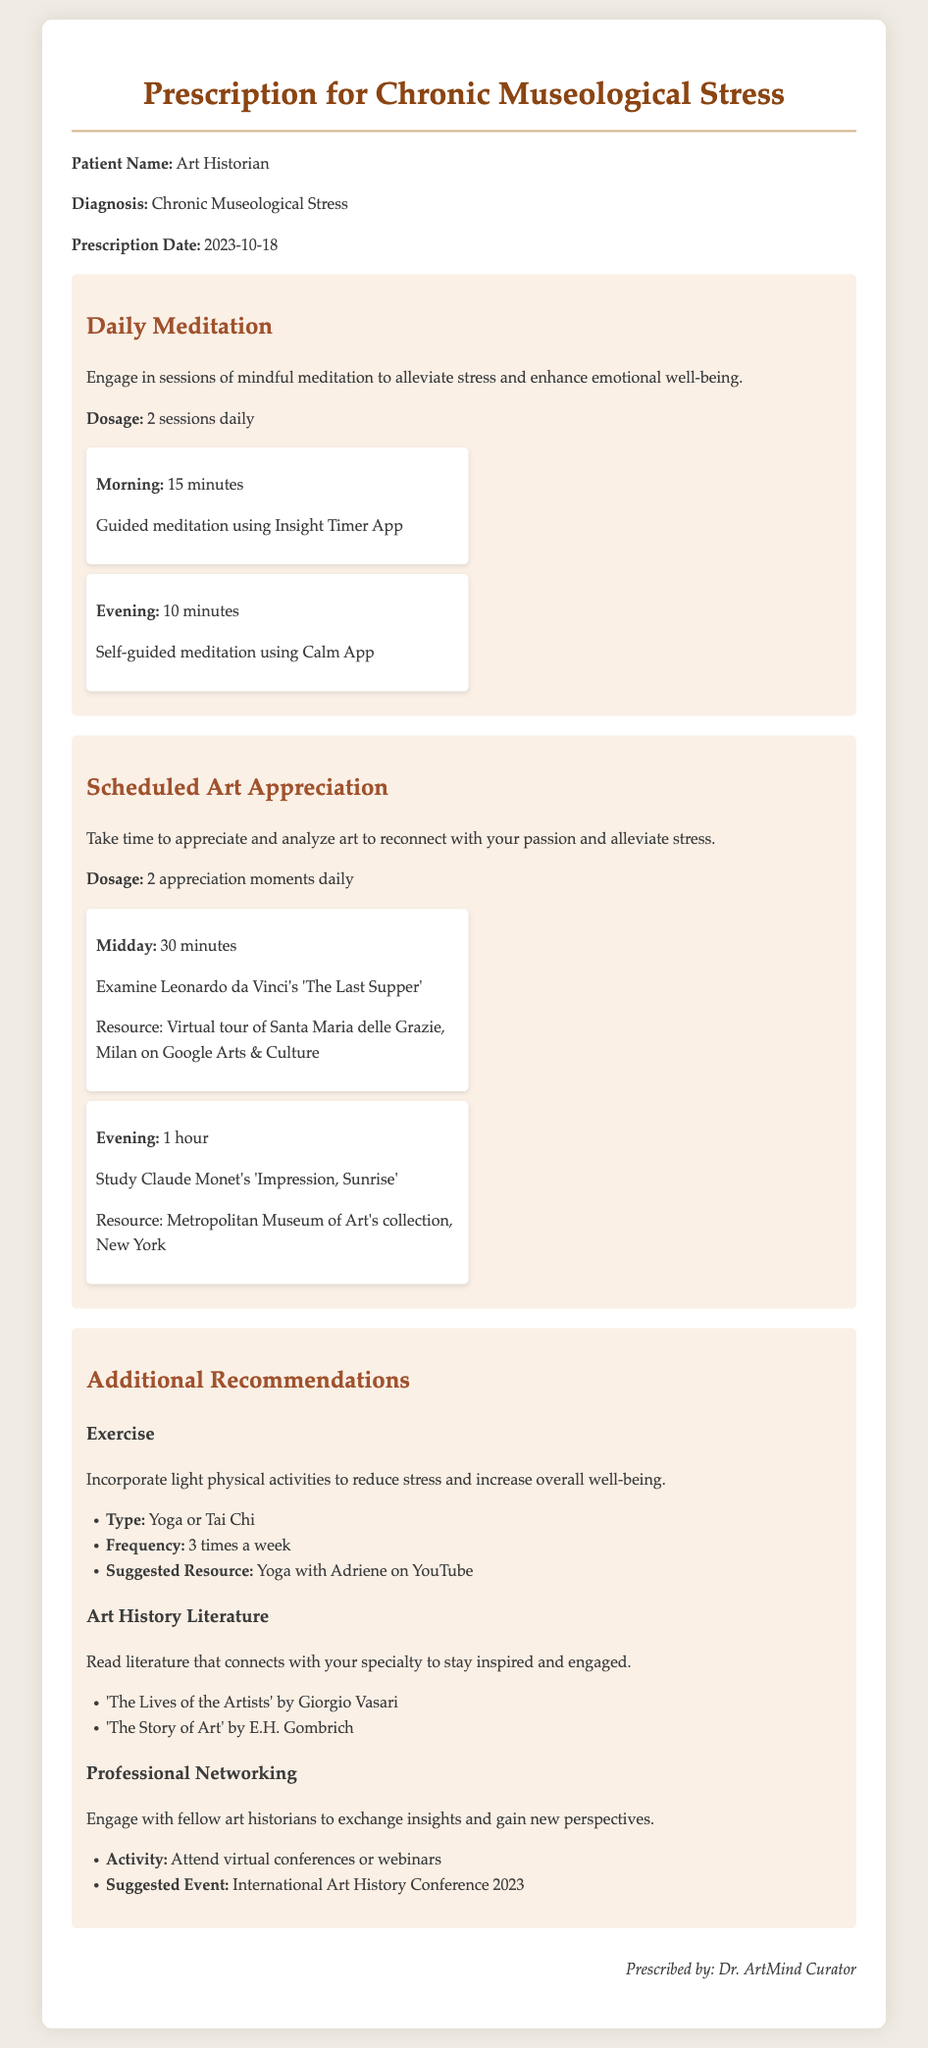What is the patient's name? The patient's name is mentioned at the beginning of the document, specifying who the prescription is for.
Answer: Art Historian What is the diagnosis? The diagnosis is stated shortly after the patient's name, indicating the specific condition being addressed.
Answer: Chronic Museological Stress How many meditation sessions are prescribed daily? The document directly specifies the frequency of meditation sessions recommended for the patient.
Answer: 2 sessions What is the duration of the morning meditation session? The document provides specific times for morning and evening sessions under daily meditation.
Answer: 15 minutes What art piece is suggested for examination at midday? The document lists specific artworks assigned for appreciation moments, including times and durations.
Answer: The Last Supper What is the suggested frequency for yoga or Tai Chi? The frequency for incorporating these activities into the patient's routine is given in the additional recommendations section.
Answer: 3 times a week Which book is recommended for art history literature? The document includes specific title recommendations under the literature section, which can be identified by their mention.
Answer: The Lives of the Artists What is the suggested resource for practicing yoga? The document provides specific resources for exercise activities mentioned under additional recommendations.
Answer: Yoga with Adriene on YouTube Who prescribed this treatment? The document includes a signature section that identifies the person prescribing the recommendations.
Answer: Dr. ArtMind Curator 